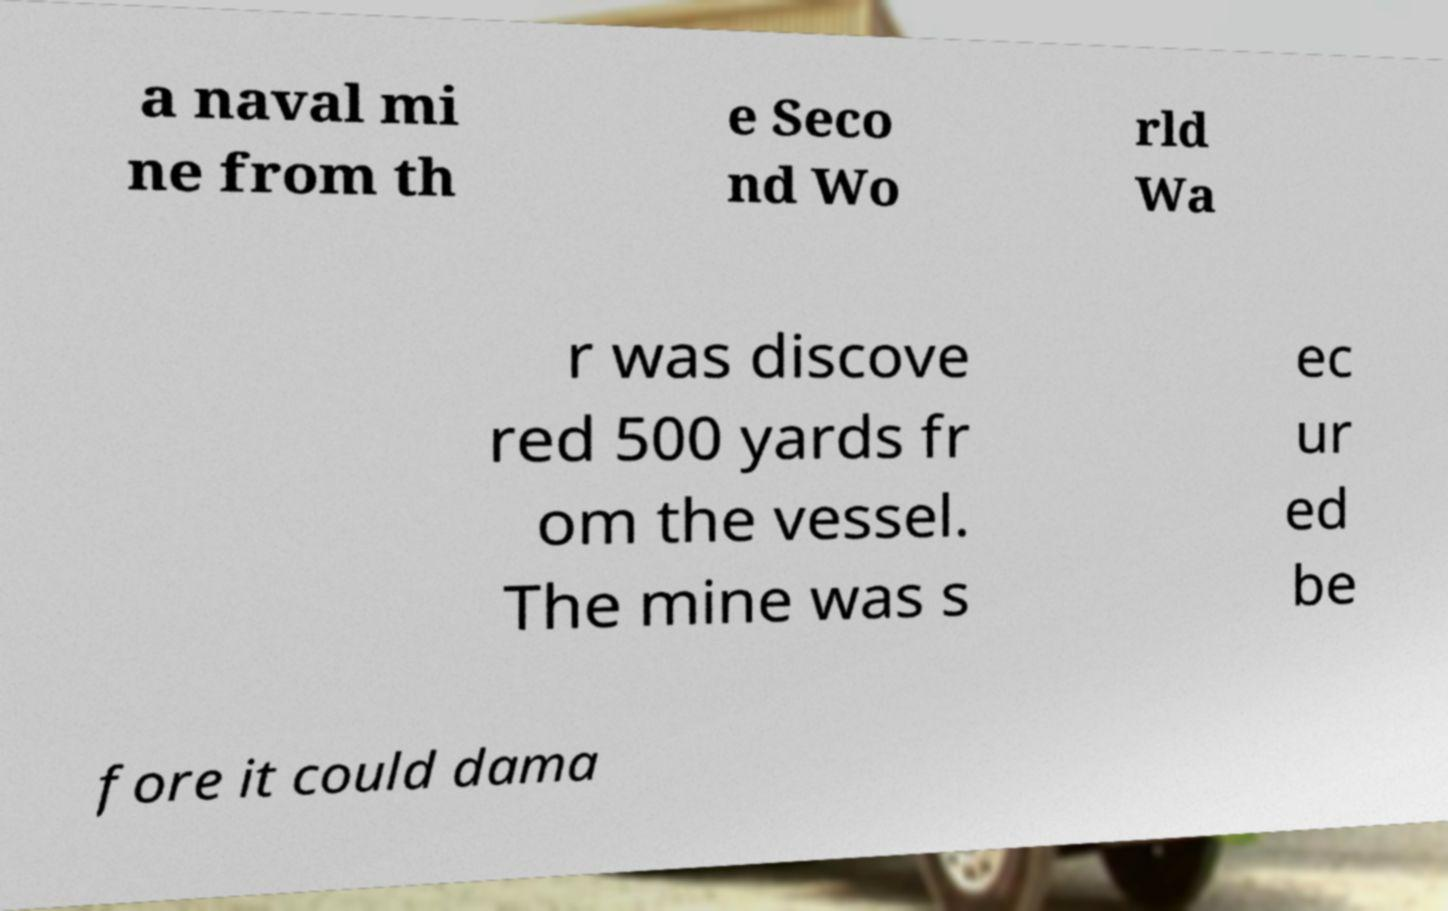Can you accurately transcribe the text from the provided image for me? a naval mi ne from th e Seco nd Wo rld Wa r was discove red 500 yards fr om the vessel. The mine was s ec ur ed be fore it could dama 